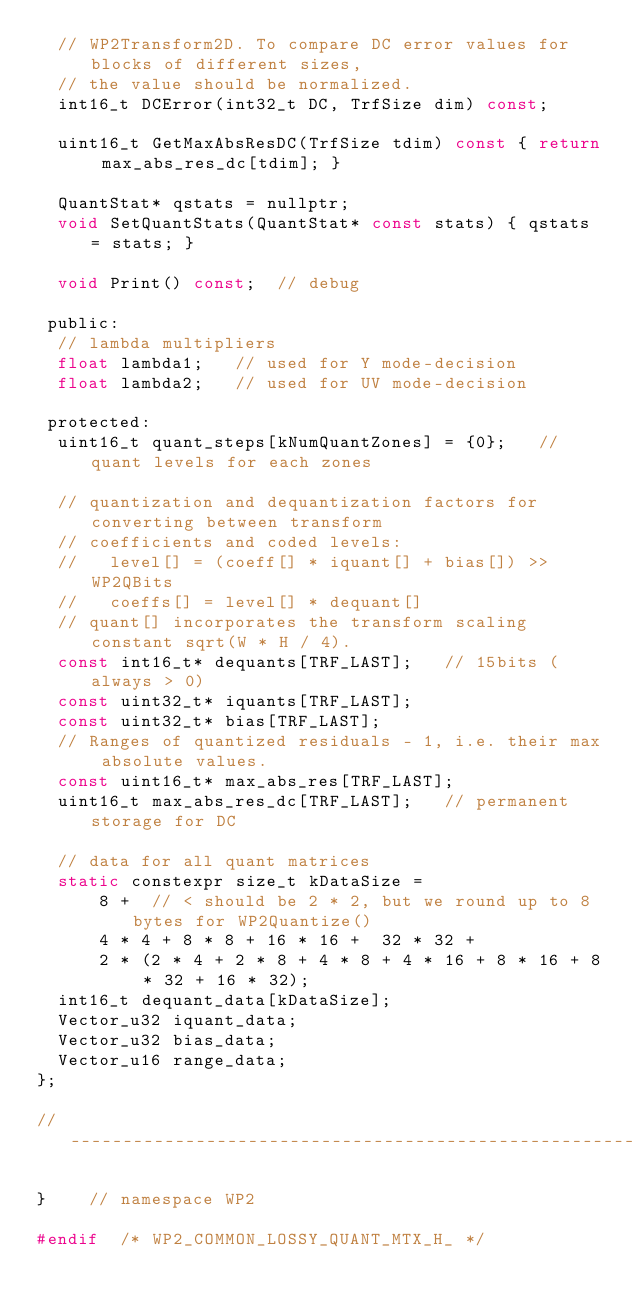<code> <loc_0><loc_0><loc_500><loc_500><_C_>  // WP2Transform2D. To compare DC error values for blocks of different sizes,
  // the value should be normalized.
  int16_t DCError(int32_t DC, TrfSize dim) const;

  uint16_t GetMaxAbsResDC(TrfSize tdim) const { return max_abs_res_dc[tdim]; }

  QuantStat* qstats = nullptr;
  void SetQuantStats(QuantStat* const stats) { qstats = stats; }

  void Print() const;  // debug

 public:
  // lambda multipliers
  float lambda1;   // used for Y mode-decision
  float lambda2;   // used for UV mode-decision

 protected:
  uint16_t quant_steps[kNumQuantZones] = {0};   // quant levels for each zones

  // quantization and dequantization factors for converting between transform
  // coefficients and coded levels:
  //   level[] = (coeff[] * iquant[] + bias[]) >> WP2QBits
  //   coeffs[] = level[] * dequant[]
  // quant[] incorporates the transform scaling constant sqrt(W * H / 4).
  const int16_t* dequants[TRF_LAST];   // 15bits (always > 0)
  const uint32_t* iquants[TRF_LAST];
  const uint32_t* bias[TRF_LAST];
  // Ranges of quantized residuals - 1, i.e. their max absolute values.
  const uint16_t* max_abs_res[TRF_LAST];
  uint16_t max_abs_res_dc[TRF_LAST];   // permanent storage for DC

  // data for all quant matrices
  static constexpr size_t kDataSize =
      8 +  // < should be 2 * 2, but we round up to 8 bytes for WP2Quantize()
      4 * 4 + 8 * 8 + 16 * 16 +  32 * 32 +
      2 * (2 * 4 + 2 * 8 + 4 * 8 + 4 * 16 + 8 * 16 + 8 * 32 + 16 * 32);
  int16_t dequant_data[kDataSize];
  Vector_u32 iquant_data;
  Vector_u32 bias_data;
  Vector_u16 range_data;
};

//------------------------------------------------------------------------------

}    // namespace WP2

#endif  /* WP2_COMMON_LOSSY_QUANT_MTX_H_ */
</code> 